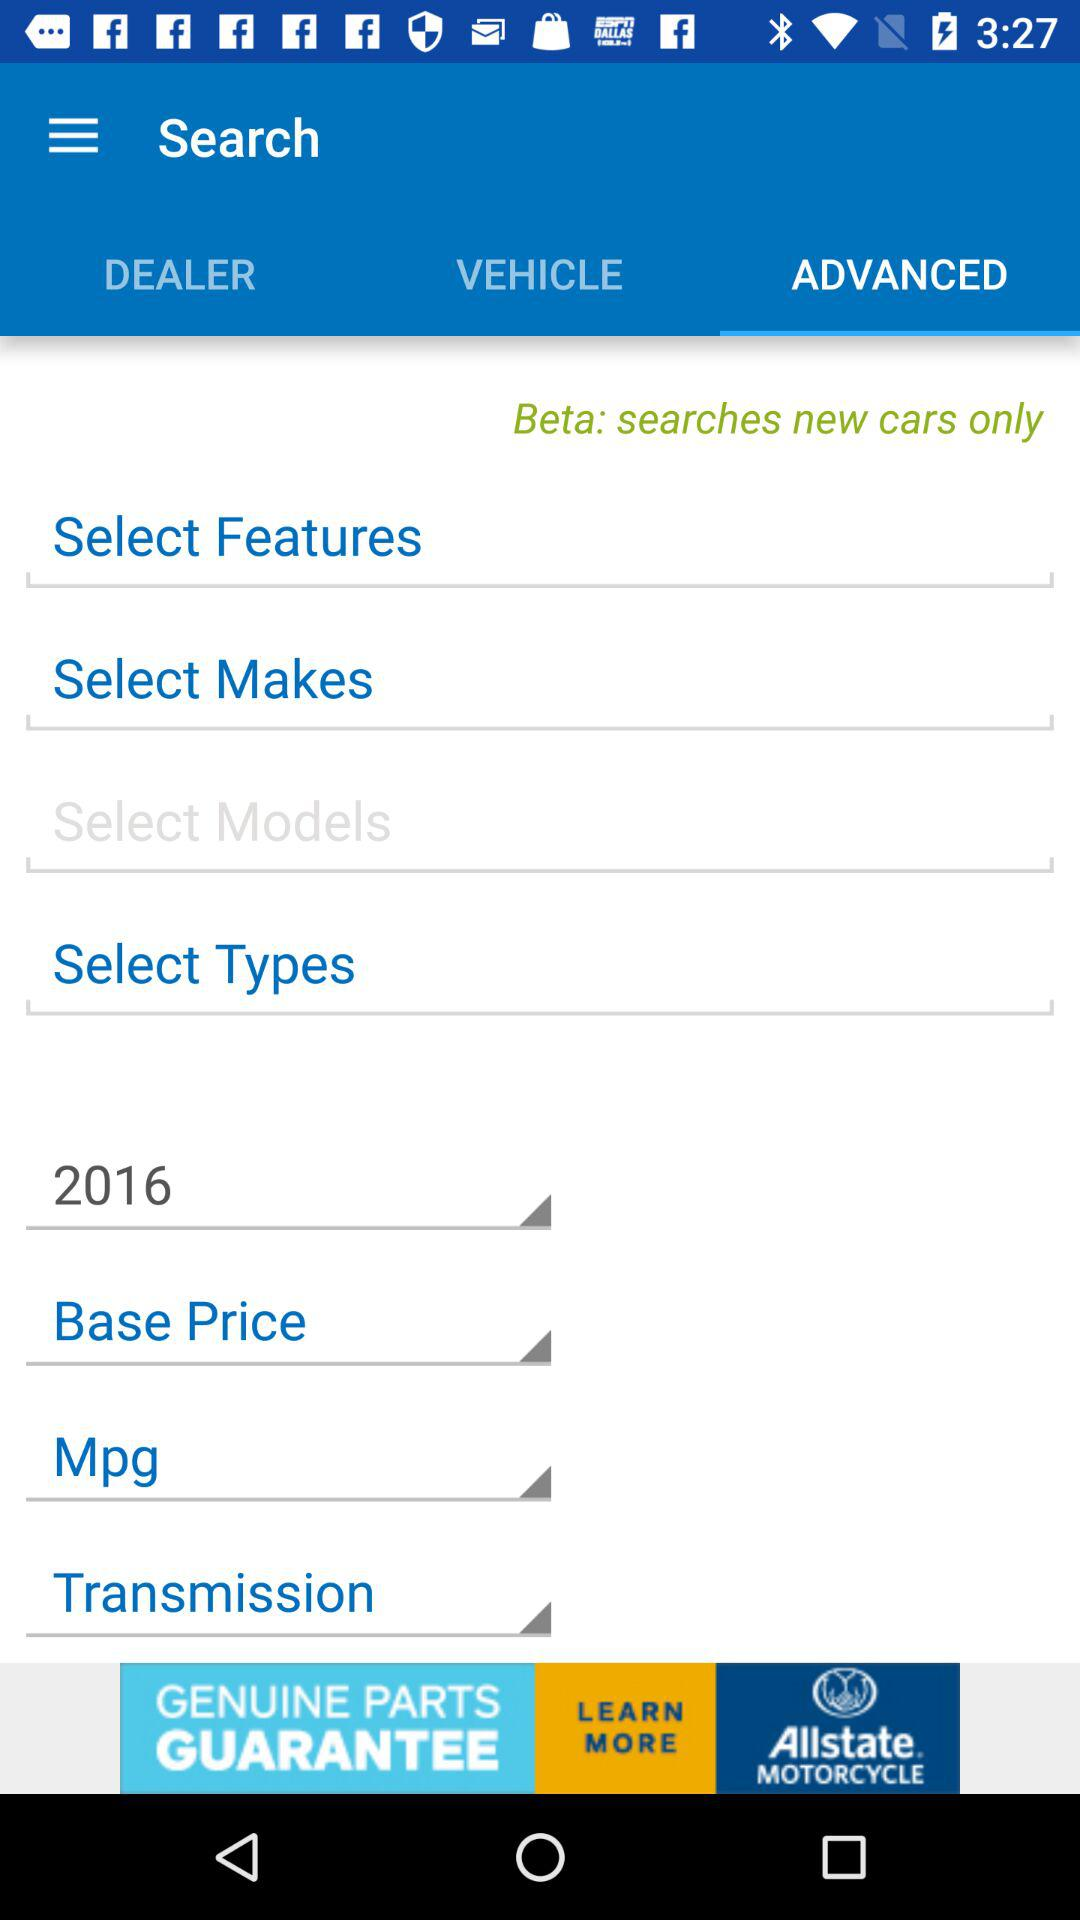Which model is selected?
When the provided information is insufficient, respond with <no answer>. <no answer> 